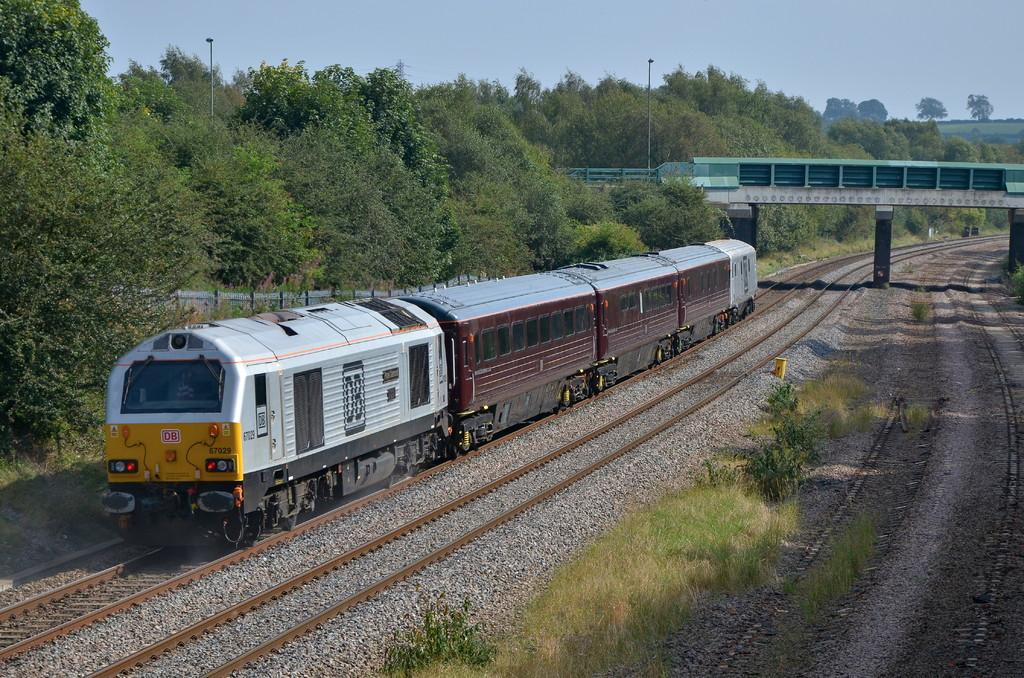What type of transportation infrastructure is visible in the image? There are railway tracks in the image. What is traveling on the railway tracks? There is a train on the tracks. What structure can be seen in the image that allows the train to cross over another object? There is a bridge in the image. What type of vegetation is present in the image? There are green trees in the image. What are the vertical structures in the image that support electrical wires? There are poles in the image. What is visible at the top of the image? The sky is visible at the top of the image. Where is the zoo located in the image? There is no zoo present in the image. What type of water feature can be seen in the middle of the image? There is no water feature or middle section of the image mentioned in the provided facts. 